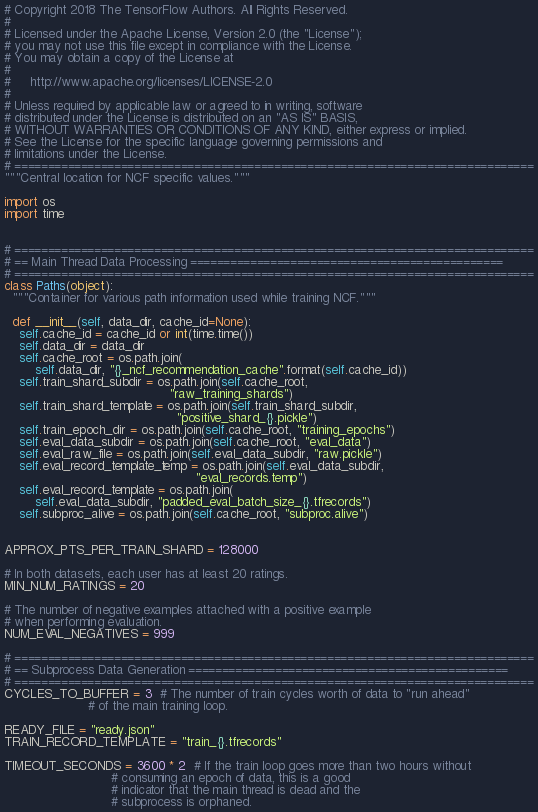Convert code to text. <code><loc_0><loc_0><loc_500><loc_500><_Python_># Copyright 2018 The TensorFlow Authors. All Rights Reserved.
#
# Licensed under the Apache License, Version 2.0 (the "License");
# you may not use this file except in compliance with the License.
# You may obtain a copy of the License at
#
#     http://www.apache.org/licenses/LICENSE-2.0
#
# Unless required by applicable law or agreed to in writing, software
# distributed under the License is distributed on an "AS IS" BASIS,
# WITHOUT WARRANTIES OR CONDITIONS OF ANY KIND, either express or implied.
# See the License for the specific language governing permissions and
# limitations under the License.
# ==============================================================================
"""Central location for NCF specific values."""

import os
import time


# ==============================================================================
# == Main Thread Data Processing ===============================================
# ==============================================================================
class Paths(object):
  """Container for various path information used while training NCF."""

  def __init__(self, data_dir, cache_id=None):
    self.cache_id = cache_id or int(time.time())
    self.data_dir = data_dir
    self.cache_root = os.path.join(
        self.data_dir, "{}_ncf_recommendation_cache".format(self.cache_id))
    self.train_shard_subdir = os.path.join(self.cache_root,
                                           "raw_training_shards")
    self.train_shard_template = os.path.join(self.train_shard_subdir,
                                             "positive_shard_{}.pickle")
    self.train_epoch_dir = os.path.join(self.cache_root, "training_epochs")
    self.eval_data_subdir = os.path.join(self.cache_root, "eval_data")
    self.eval_raw_file = os.path.join(self.eval_data_subdir, "raw.pickle")
    self.eval_record_template_temp = os.path.join(self.eval_data_subdir,
                                                  "eval_records.temp")
    self.eval_record_template = os.path.join(
        self.eval_data_subdir, "padded_eval_batch_size_{}.tfrecords")
    self.subproc_alive = os.path.join(self.cache_root, "subproc.alive")


APPROX_PTS_PER_TRAIN_SHARD = 128000

# In both datasets, each user has at least 20 ratings.
MIN_NUM_RATINGS = 20

# The number of negative examples attached with a positive example
# when performing evaluation.
NUM_EVAL_NEGATIVES = 999

# ==============================================================================
# == Subprocess Data Generation ================================================
# ==============================================================================
CYCLES_TO_BUFFER = 3  # The number of train cycles worth of data to "run ahead"
                      # of the main training loop.

READY_FILE = "ready.json"
TRAIN_RECORD_TEMPLATE = "train_{}.tfrecords"

TIMEOUT_SECONDS = 3600 * 2  # If the train loop goes more than two hours without
                            # consuming an epoch of data, this is a good
                            # indicator that the main thread is dead and the
                            # subprocess is orphaned.
</code> 